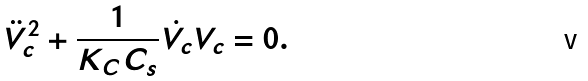<formula> <loc_0><loc_0><loc_500><loc_500>\ddot { V } _ { c } ^ { 2 } + \frac { 1 } { K _ { C } C _ { s } } \dot { V _ { c } } V _ { c } = 0 .</formula> 